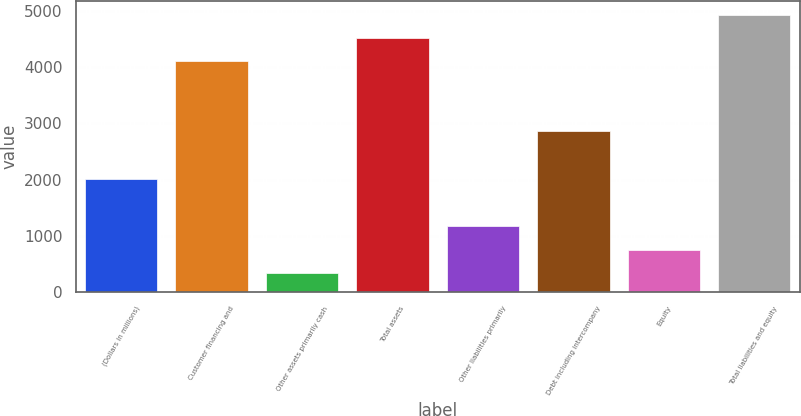<chart> <loc_0><loc_0><loc_500><loc_500><bar_chart><fcel>(Dollars in millions)<fcel>Customer financing and<fcel>Other assets primarily cash<fcel>Total assets<fcel>Other liabilities primarily<fcel>Debt including intercompany<fcel>Equity<fcel>Total liabilities and equity<nl><fcel>2016<fcel>4109<fcel>346<fcel>4519.9<fcel>1167.8<fcel>2864<fcel>756.9<fcel>4930.8<nl></chart> 